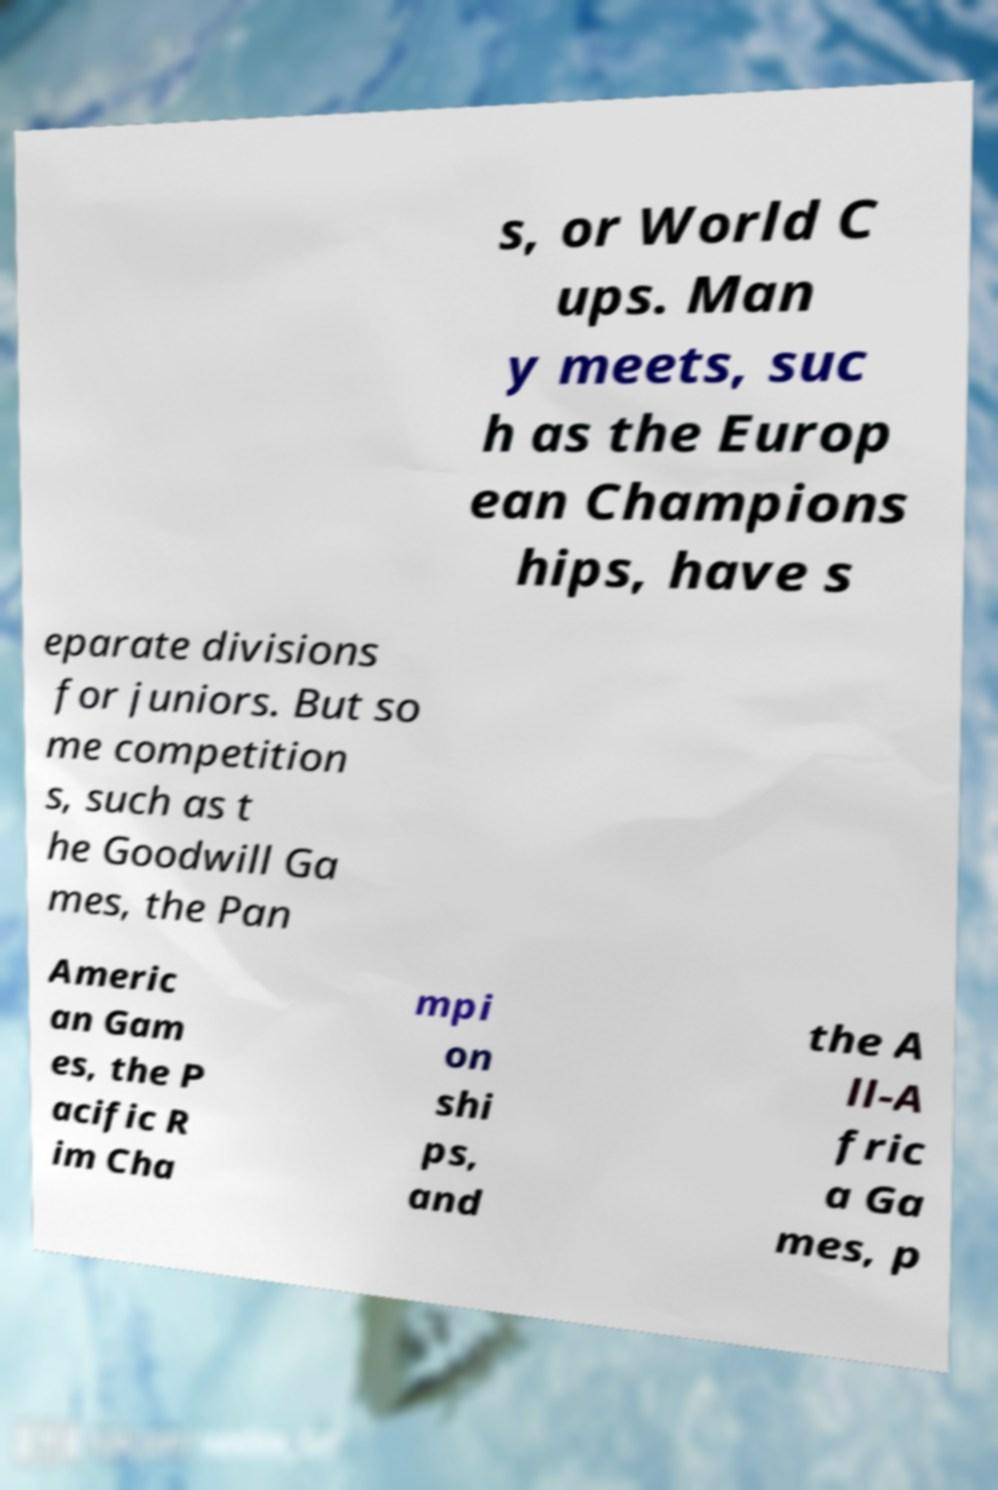Could you assist in decoding the text presented in this image and type it out clearly? s, or World C ups. Man y meets, suc h as the Europ ean Champions hips, have s eparate divisions for juniors. But so me competition s, such as t he Goodwill Ga mes, the Pan Americ an Gam es, the P acific R im Cha mpi on shi ps, and the A ll-A fric a Ga mes, p 